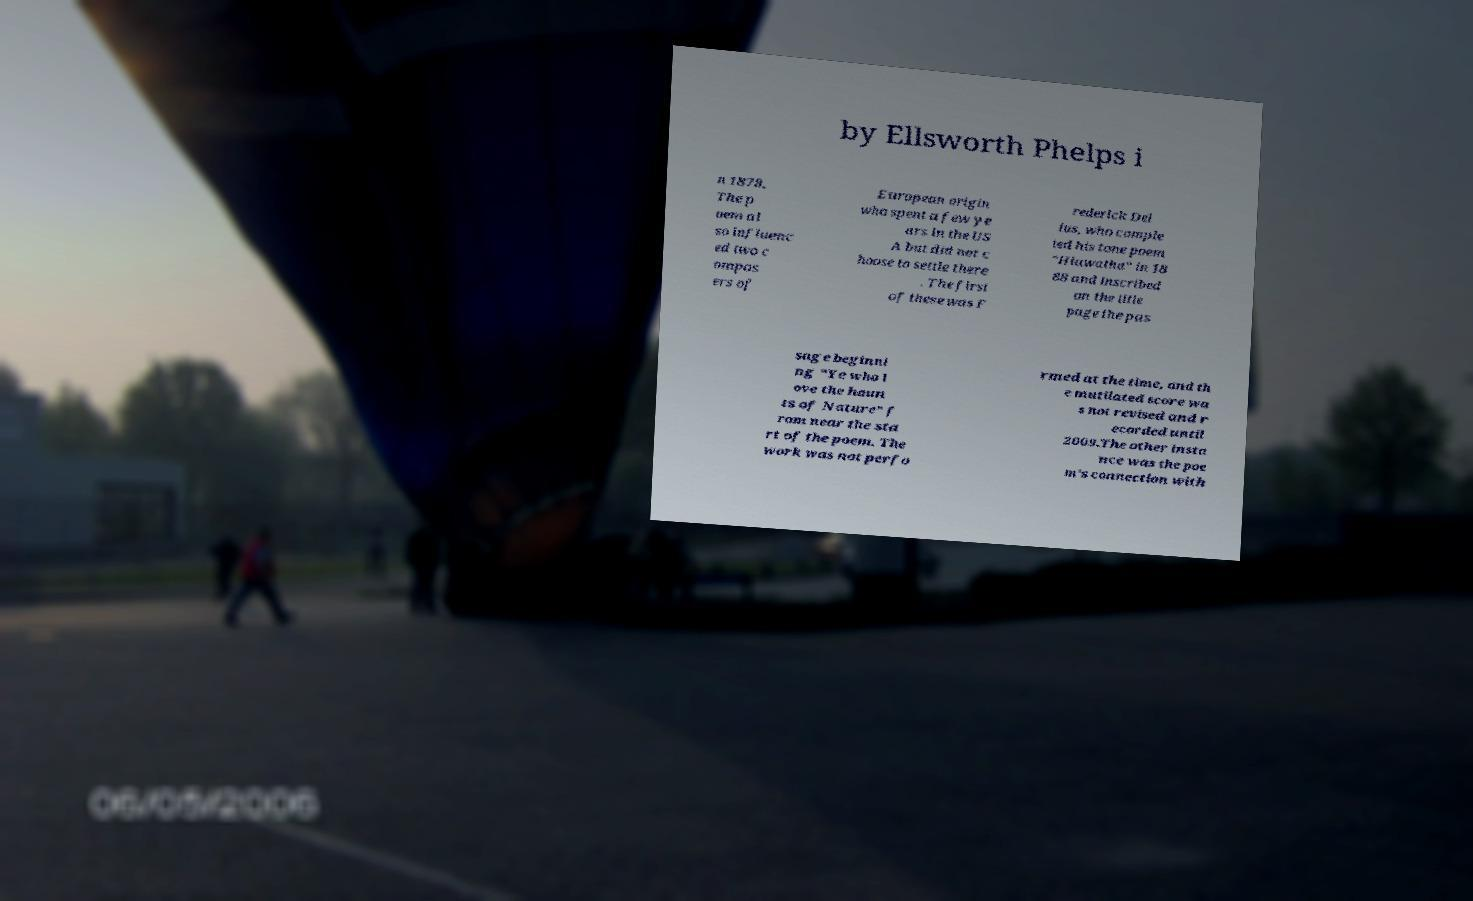Could you assist in decoding the text presented in this image and type it out clearly? by Ellsworth Phelps i n 1878. The p oem al so influenc ed two c ompos ers of European origin who spent a few ye ars in the US A but did not c hoose to settle there . The first of these was F rederick Del ius, who comple ted his tone poem "Hiawatha" in 18 88 and inscribed on the title page the pas sage beginni ng “Ye who l ove the haun ts of Nature” f rom near the sta rt of the poem. The work was not perfo rmed at the time, and th e mutilated score wa s not revised and r ecorded until 2009.The other insta nce was the poe m's connection with 